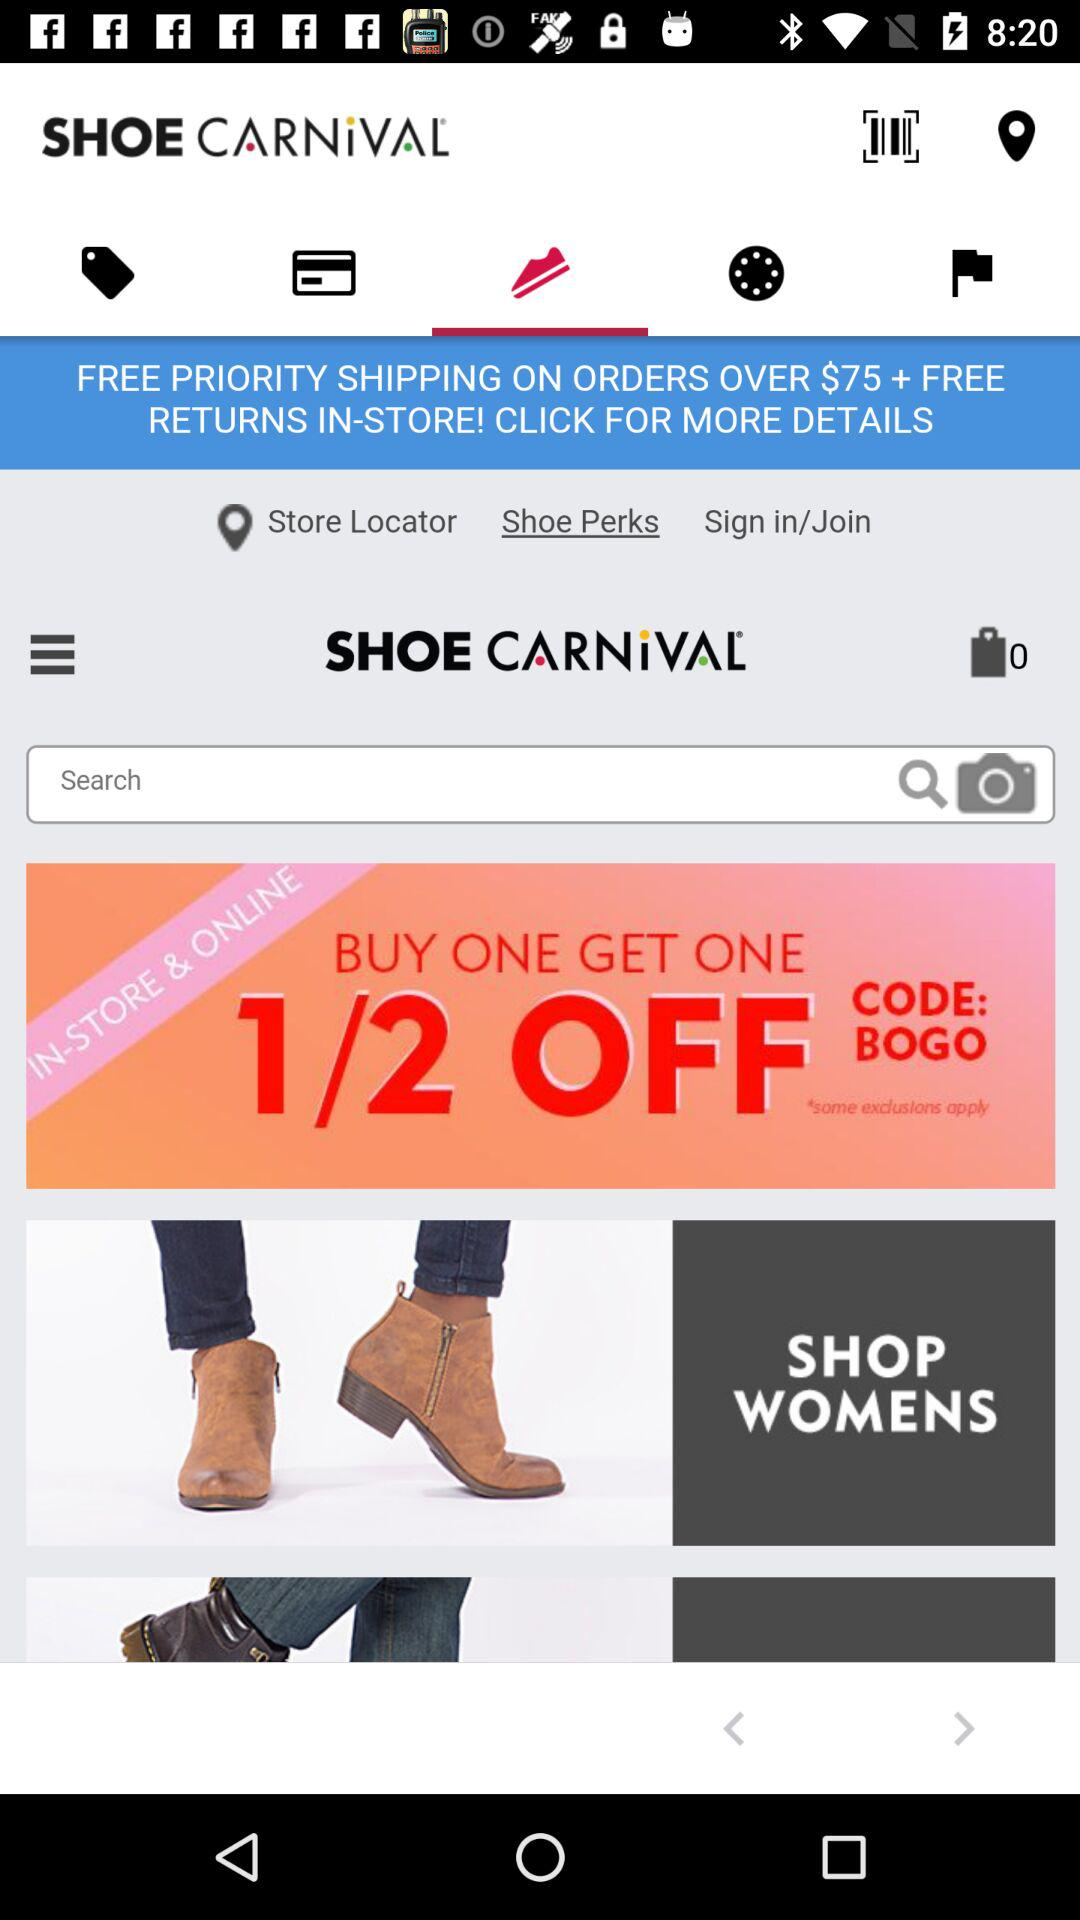Which tab has been selected? The tab that has been selected is "Shoes". 